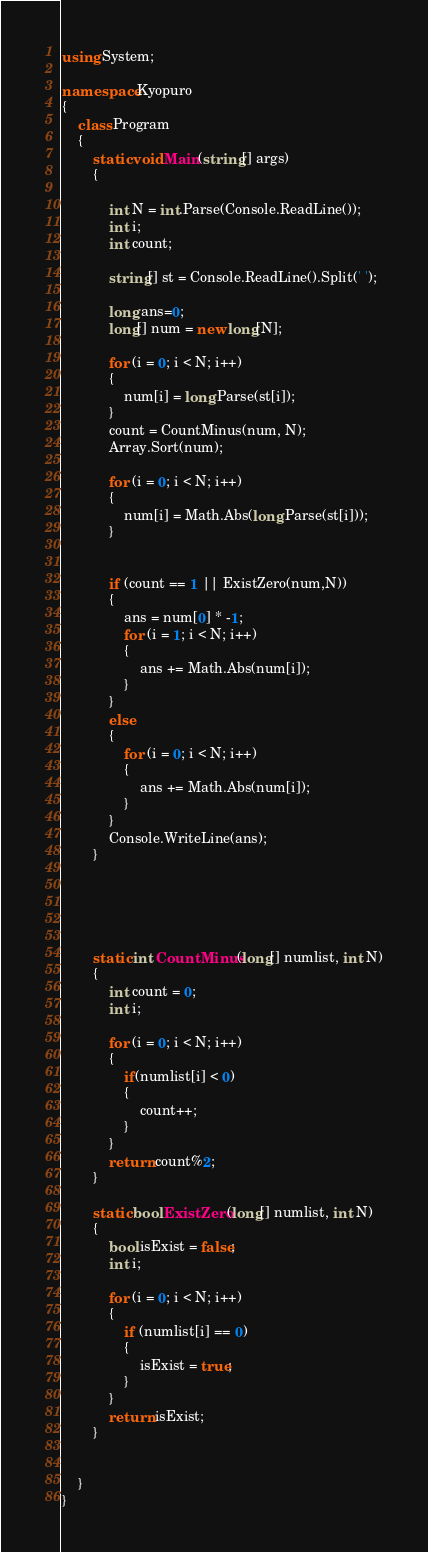Convert code to text. <code><loc_0><loc_0><loc_500><loc_500><_C#_>using System;

namespace Kyopuro
{
    class Program
    {
        static void Main(string[] args)
        {

            int N = int.Parse(Console.ReadLine());
            int i;
            int count;

            string[] st = Console.ReadLine().Split(' ');

            long ans=0;
            long[] num = new long[N];

            for (i = 0; i < N; i++)
            {
                num[i] = long.Parse(st[i]);
            }
            count = CountMinus(num, N);
            Array.Sort(num);

            for (i = 0; i < N; i++)
            {
                num[i] = Math.Abs(long.Parse(st[i]));
            }


            if (count == 1 || ExistZero(num,N))
            {
                ans = num[0] * -1;
                for (i = 1; i < N; i++)
                {
                    ans += Math.Abs(num[i]);
                }
            }
            else
            {
                for (i = 0; i < N; i++)
                {
                    ans += Math.Abs(num[i]);
                }
            }
            Console.WriteLine(ans);
        }





        static int CountMinus(long[] numlist, int N)
        {
            int count = 0;
            int i;

            for (i = 0; i < N; i++)
            {
                if(numlist[i] < 0)
                {
                    count++;
                }
            }
            return count%2;
        }

        static bool ExistZero(long[] numlist, int N)
        {
            bool isExist = false;
            int i;

            for (i = 0; i < N; i++)
            {
                if (numlist[i] == 0)
                {
                    isExist = true;
                }
            }
            return isExist;
        }


    }
}</code> 